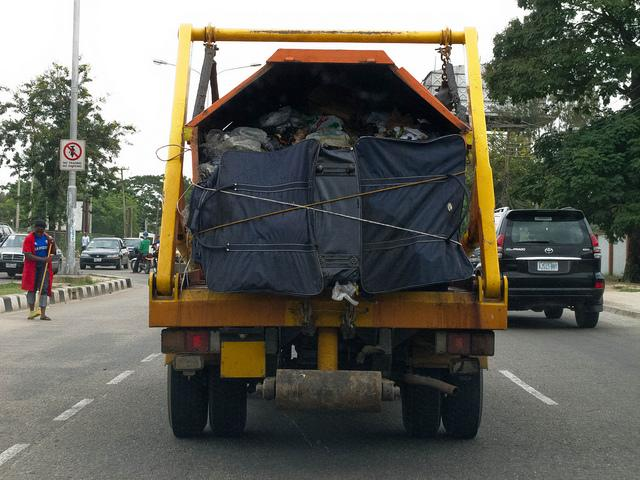Where might the truck in yellow be headed?

Choices:
A) car lot
B) home
C) junk yard
D) grocery store junk yard 